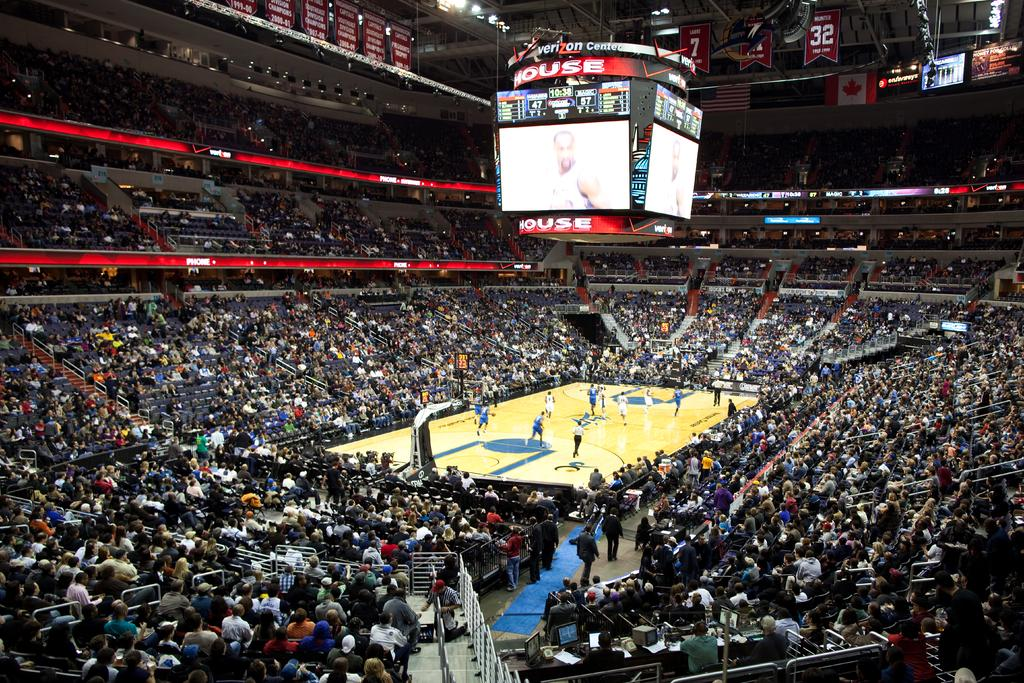<image>
Present a compact description of the photo's key features. A crowd of people are watching a basketball game at the Verizon Center. 